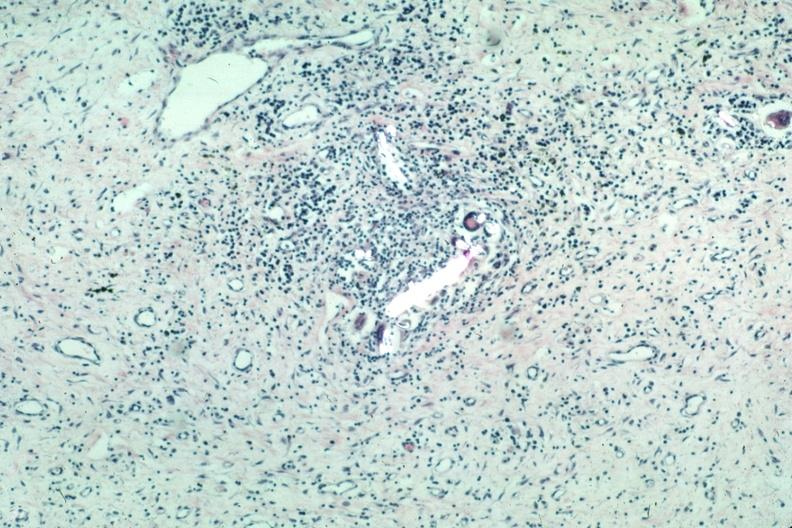does this image show with partially crossed polarizing to show foreign material very typical?
Answer the question using a single word or phrase. Yes 